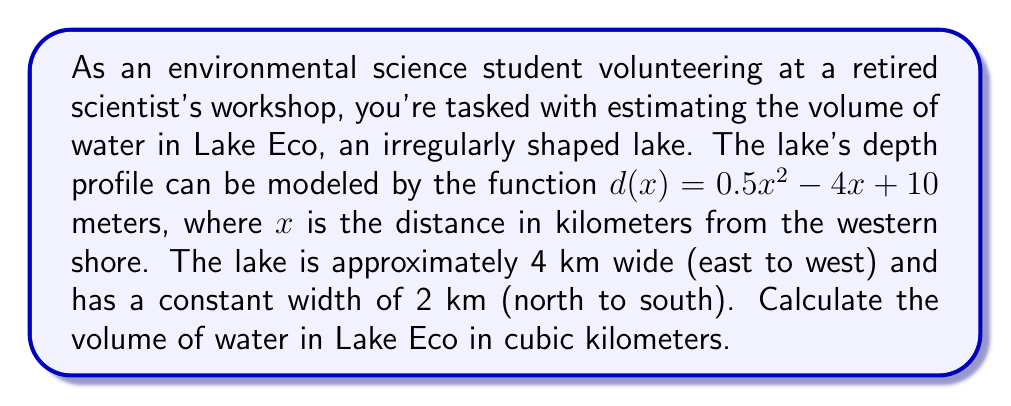Solve this math problem. To solve this problem, we'll use integration techniques to calculate the volume of the irregularly shaped lake. Here's a step-by-step approach:

1) The volume of the lake can be calculated by integrating the cross-sectional area over the width of the lake. The cross-sectional area at any point x is the product of the depth d(x) and the constant width of the lake.

2) Set up the integral:
   $$V = \int_0^4 2 \cdot d(x) \, dx$$
   where 2 is the constant width in km, and the limits of integration are from 0 to 4 km (the width of the lake).

3) Substitute the depth function:
   $$V = \int_0^4 2 \cdot (0.5x^2 - 4x + 10) \, dx$$

4) Simplify:
   $$V = \int_0^4 (x^2 - 8x + 20) \, dx$$

5) Integrate:
   $$V = \left[ \frac{1}{3}x^3 - 4x^2 + 20x \right]_0^4$$

6) Evaluate the definite integral:
   $$V = \left(\frac{1}{3}(4^3) - 4(4^2) + 20(4)\right) - \left(\frac{1}{3}(0^3) - 4(0^2) + 20(0)\right)$$
   $$V = \left(\frac{64}{3} - 64 + 80\right) - (0)$$
   $$V = \frac{64}{3} + 16 = \frac{112}{3} \approx 37.33$$

7) The result is in cubic kilometers.
Answer: The volume of water in Lake Eco is $\frac{112}{3}$ cubic kilometers or approximately 37.33 cubic kilometers. 